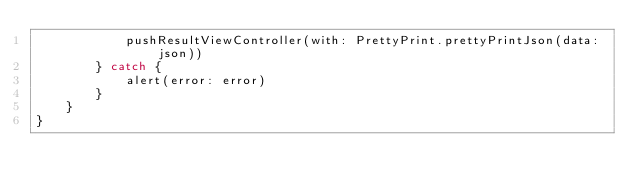<code> <loc_0><loc_0><loc_500><loc_500><_Swift_>            pushResultViewController(with: PrettyPrint.prettyPrintJson(data: json))
        } catch {
            alert(error: error)
        }
    }
}
</code> 